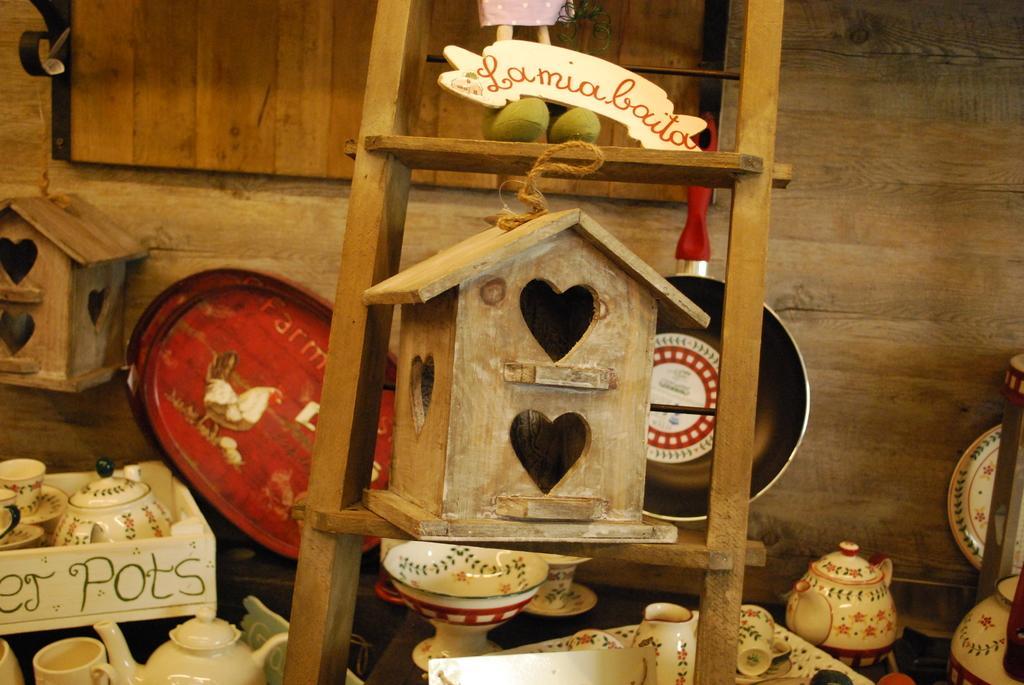How would you summarize this image in a sentence or two? In this picture there is an artificial wooden house and there is a toy on the ladder. There are cups, mugs, bowls, plates and there is a tray, pan on the table and there is an artificial wooden house hanging. At the back there is a wooden wall. 